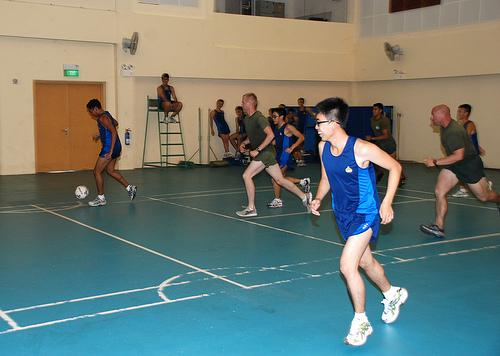What type of facilities can you see on the wall in the image? There is a loudspeaker and a wall mounted ceiling fan on the wall. Identify some objects found near or at the doors. A green exit sign, blue fire extinguisher, and a brown door are found near the entrance to the gym. What is noticeable about the man wearing glasses? The man wearing glasses is also wearing a blue shirt, and he seems to be an Asian man. What sport are the people playing in the image? The people are playing soccer in an indoor gym. Provide a brief description of the surroundings in the image. The image shows an indoor playing ground with people playing soccer, white lines on the floor, a loudspeaker on the wall, and a green exit sign above a door. What is the color of the two main teams' uniforms in this photo? The two main teams' uniforms are blue and green. Comment on the state of the soccer ball during the game The soccer ball is being kicked and is in motion during the game. Can you see any spectators or non-players in the image? If so, describe them. Yes, there is a man sitting on a ladder and another man watching the game. Both of them seem to be observing the soccer match. Analyze the role of the woman in blue leaning on the wall. The woman in blue leaning on the wall might be observing the game or waiting for her turn to play. Describe the appearance of the person sitting on a tall chair. The person sitting on the tall chair is a woman who appears to be watching the game, possibly acting as a referee or a coach. Describe the atmosphere of the image. Competitive and energetic Which objects are the participants interacting with while playing soccer? Soccer ball and gym floor What is the color of the uniform worn by the boy running in the foreground? Blue Provide a short descriptive phrase that refers to the man kicking the soccer ball. "Man in blue uniform kicking soccer ball." Is the gym floor primarily a warm color or a cool color? Cool color Rate the image quality from 1 to 5 with 1 being the lowest and 5 being the highest. 4 What is being worn around the wrist of the man with the shaved head? A black wristwatch. Read any text or symbols present in the image. "Exit sign with green letters." Describe the clothing of the man watching the game. Green shirt and green shorts Identify a safety equipment present in the gym. Blue fire extinguisher next to the door. A female referee can be seen standing in the center of the soccer field. No, it's not mentioned in the image. Are there any animals or plants present in the image? No What is the primary activity taking place in the image? People playing soccer in an indoor gym List out the different types of shoes visible in the image. White pair of shoes, green and white sneakers, black and gray shoe, white tennis shoes. What type of footwear is worn by the person kicking the soccer ball? White tennis shoes. What is the interaction between the man kicking the soccer ball and the soccer ball? The man is kicking the soccer ball. Identify areas of the image where the floor is visible. Top left corner extending down and right Count the number of people appearing in the image. 7 Are there any musical instruments or sound equipment visible in the image? Yes, a loudspeaker on the wall. 